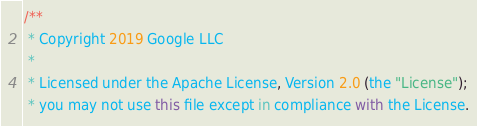<code> <loc_0><loc_0><loc_500><loc_500><_TypeScript_>/**
 * Copyright 2019 Google LLC
 *
 * Licensed under the Apache License, Version 2.0 (the "License");
 * you may not use this file except in compliance with the License.</code> 